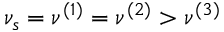<formula> <loc_0><loc_0><loc_500><loc_500>\nu _ { s } = \nu ^ { ( 1 ) } = \nu ^ { ( 2 ) } > \nu ^ { ( 3 ) }</formula> 